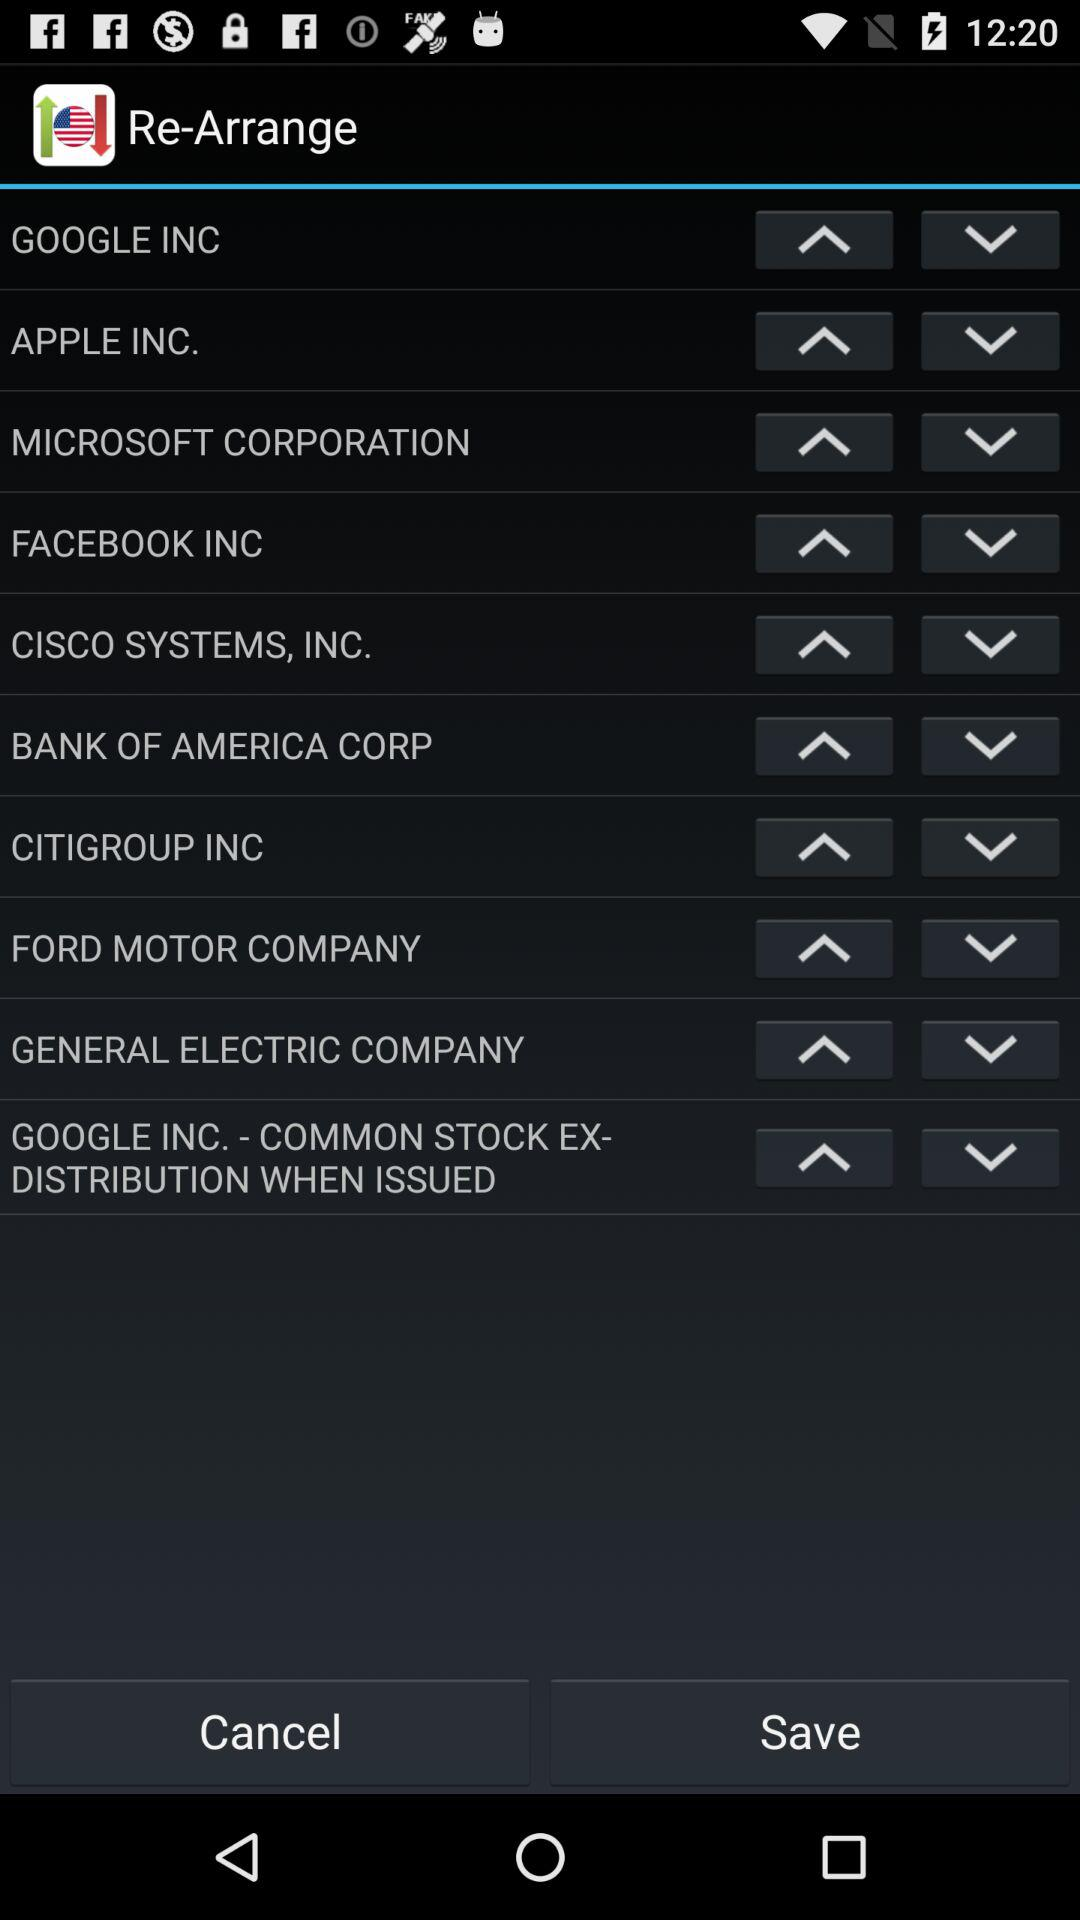Which company has the longest name?
Answer the question using a single word or phrase. GOOGLE INC. - COMMON STOCK EX- DISTRIBUTION WHEN ISSUED 